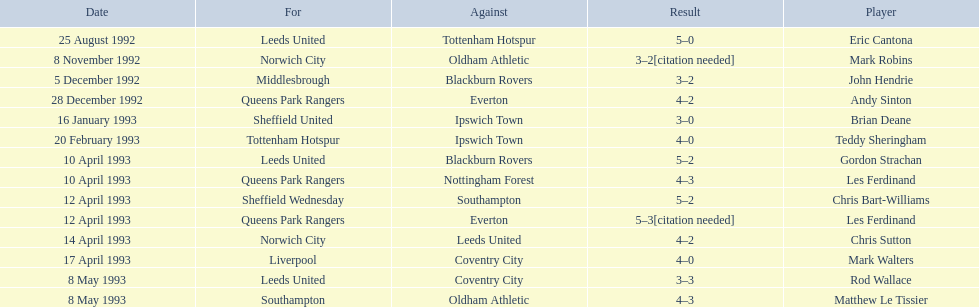Who are all the players? Eric Cantona, Mark Robins, John Hendrie, Andy Sinton, Brian Deane, Teddy Sheringham, Gordon Strachan, Les Ferdinand, Chris Bart-Williams, Les Ferdinand, Chris Sutton, Mark Walters, Rod Wallace, Matthew Le Tissier. What were their results? 5–0, 3–2[citation needed], 3–2, 4–2, 3–0, 4–0, 5–2, 4–3, 5–2, 5–3[citation needed], 4–2, 4–0, 3–3, 4–3. Which player tied with mark robins? John Hendrie. 